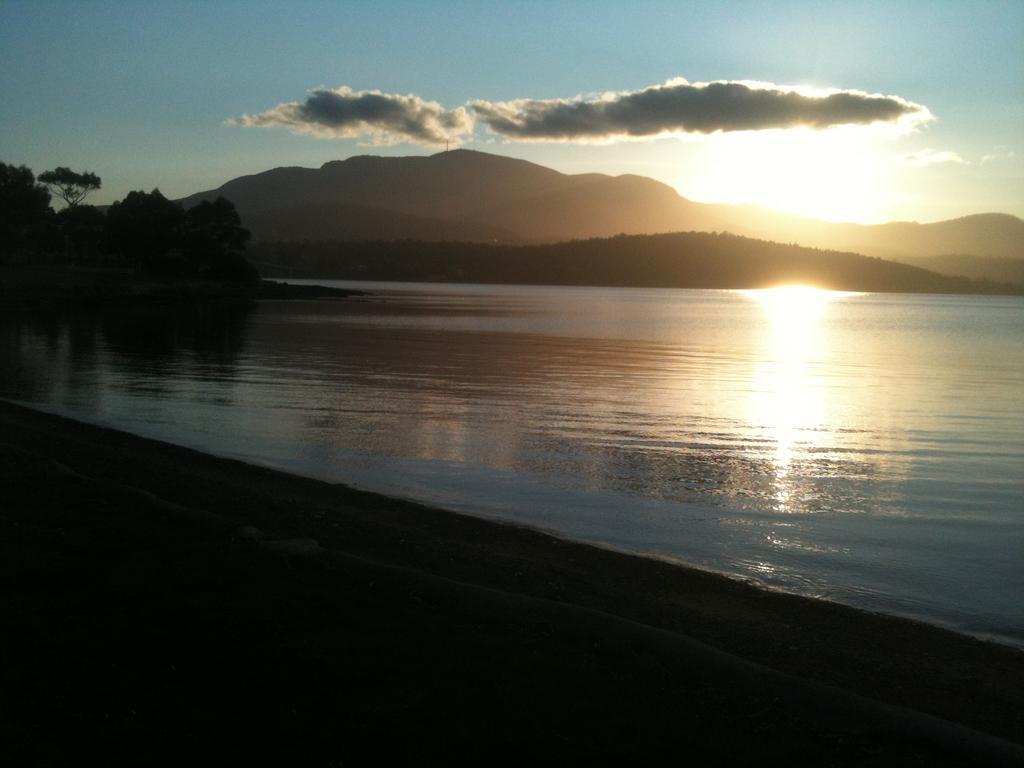In one or two sentences, can you explain what this image depicts? In the picture we can see water and in the background, we can see some trees, hills, sky with clouds and sun. 